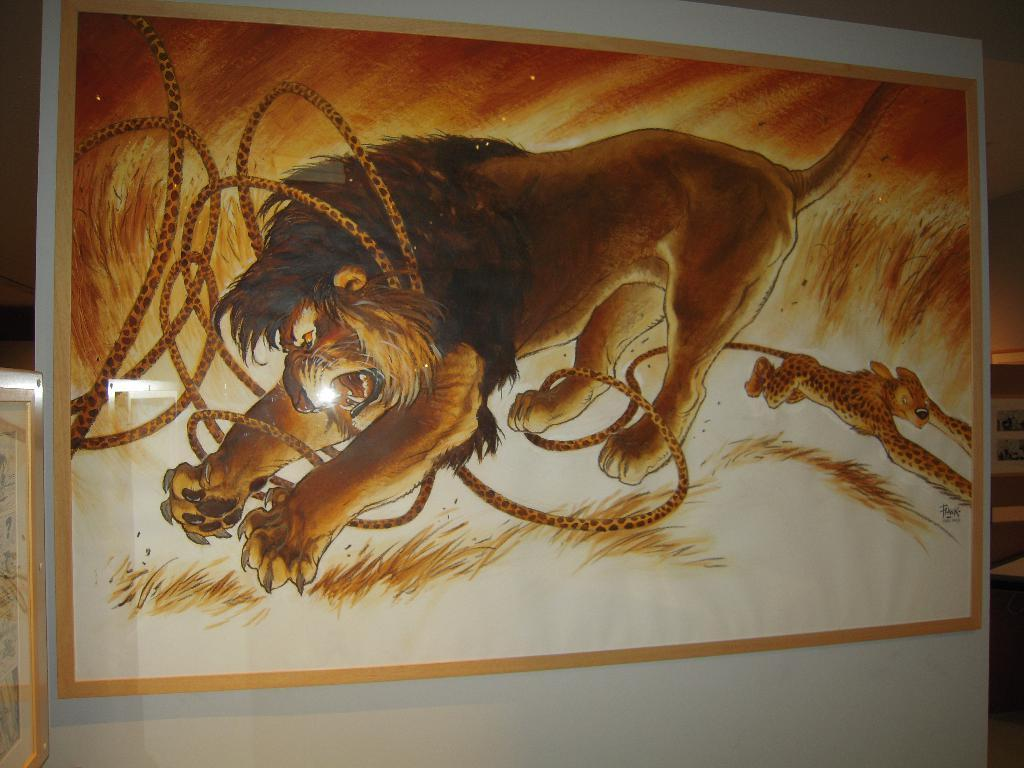What is depicted in the painting in the image? There is a painting of animals in the image. What object can be seen in addition to the painting? There is a rope visible in the image. What type of natural environment is shown in the image? There is grass in the image. What type of chin can be seen on the animals in the painting? There is no chin visible on the animals in the painting, as it is a two-dimensional representation. 